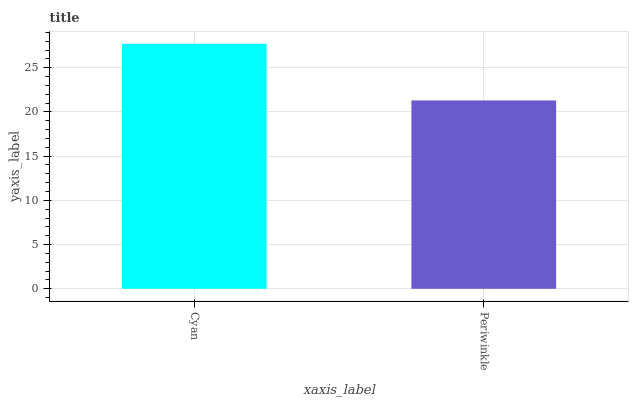Is Periwinkle the maximum?
Answer yes or no. No. Is Cyan greater than Periwinkle?
Answer yes or no. Yes. Is Periwinkle less than Cyan?
Answer yes or no. Yes. Is Periwinkle greater than Cyan?
Answer yes or no. No. Is Cyan less than Periwinkle?
Answer yes or no. No. Is Cyan the high median?
Answer yes or no. Yes. Is Periwinkle the low median?
Answer yes or no. Yes. Is Periwinkle the high median?
Answer yes or no. No. Is Cyan the low median?
Answer yes or no. No. 